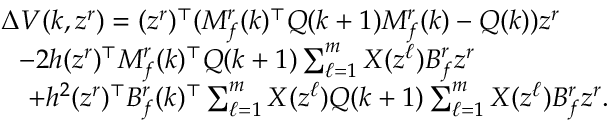Convert formula to latex. <formula><loc_0><loc_0><loc_500><loc_500>\begin{array} { r l } & { \Delta V ( k , z ^ { r } ) = ( z ^ { r } ) ^ { \top } ( M _ { f } ^ { r } ( k ) ^ { \top } Q ( k + 1 ) M _ { f } ^ { r } ( k ) - Q ( k ) ) z ^ { r } } \\ & { - 2 h ( z ^ { r } ) ^ { \top } M _ { f } ^ { r } ( k ) ^ { \top } Q ( k + 1 ) \sum _ { \ell = 1 } ^ { m } X ( z ^ { \ell } ) B _ { f } ^ { r } z ^ { r } } \\ & { + h ^ { 2 } ( z ^ { r } ) ^ { \top } B _ { f } ^ { r } ( k ) ^ { \top } \sum _ { \ell = 1 } ^ { m } X ( z ^ { \ell } ) Q ( k + 1 ) \sum _ { \ell = 1 } ^ { m } X ( z ^ { \ell } ) B _ { f } ^ { r } z ^ { r } . } \end{array}</formula> 